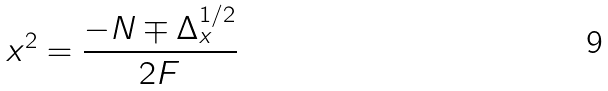<formula> <loc_0><loc_0><loc_500><loc_500>x ^ { 2 } = \frac { - N \mp \Delta ^ { 1 / 2 } _ { x } } { 2 F }</formula> 